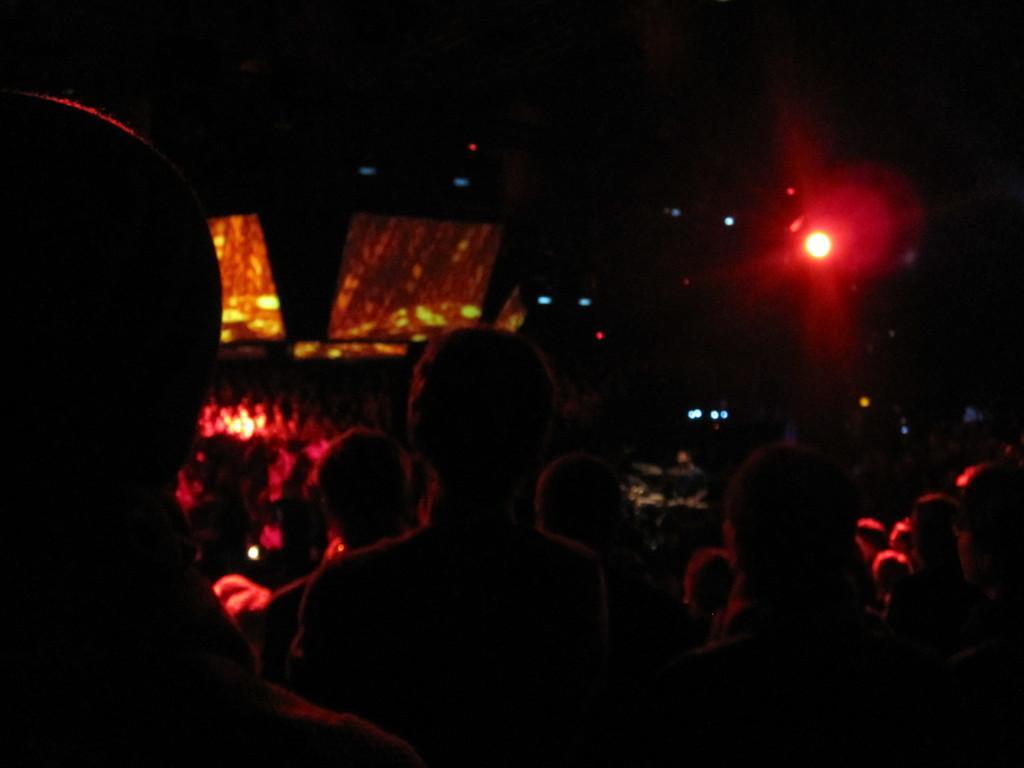Could you give a brief overview of what you see in this image? In this picture we can see few people and lights, and also we can see dark background. 